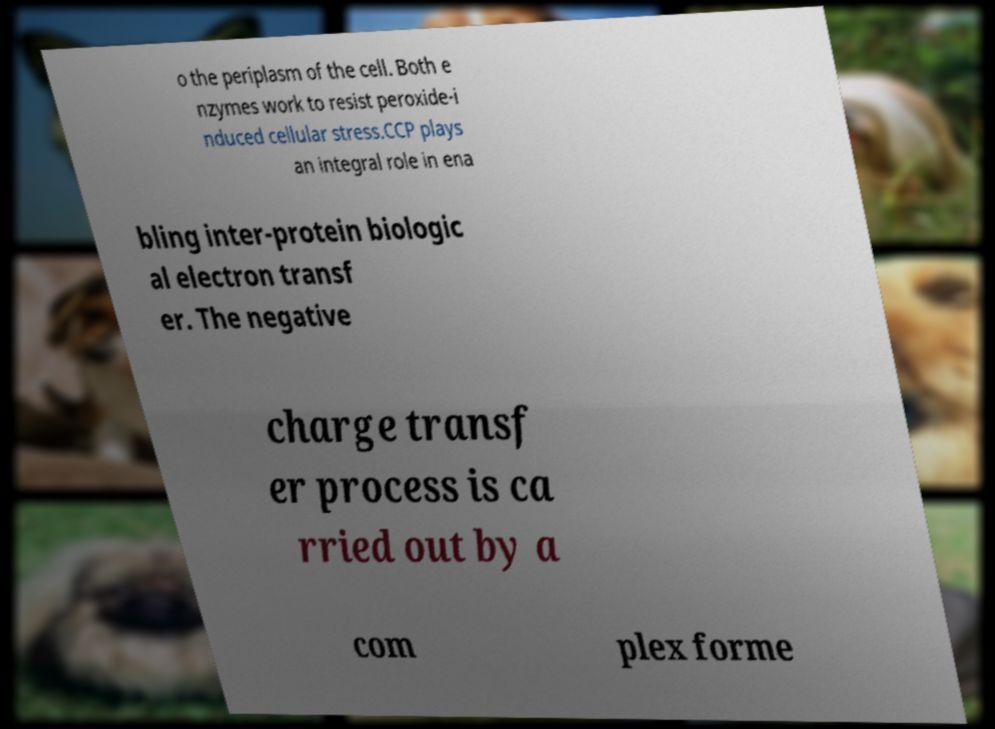Could you extract and type out the text from this image? o the periplasm of the cell. Both e nzymes work to resist peroxide-i nduced cellular stress.CCP plays an integral role in ena bling inter-protein biologic al electron transf er. The negative charge transf er process is ca rried out by a com plex forme 